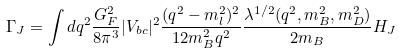Convert formula to latex. <formula><loc_0><loc_0><loc_500><loc_500>\Gamma _ { J } = \int d q ^ { 2 } \frac { G _ { F } ^ { 2 } } { 8 \pi ^ { 3 } } | V _ { b c } | ^ { 2 } \frac { ( q ^ { 2 } - m _ { l } ^ { 2 } ) ^ { 2 } } { 1 2 m _ { B } ^ { 2 } q ^ { 2 } } \frac { \lambda ^ { 1 / 2 } ( q ^ { 2 } , m _ { B } ^ { 2 } , m _ { D } ^ { 2 } ) } { 2 m _ { B } } H _ { J }</formula> 